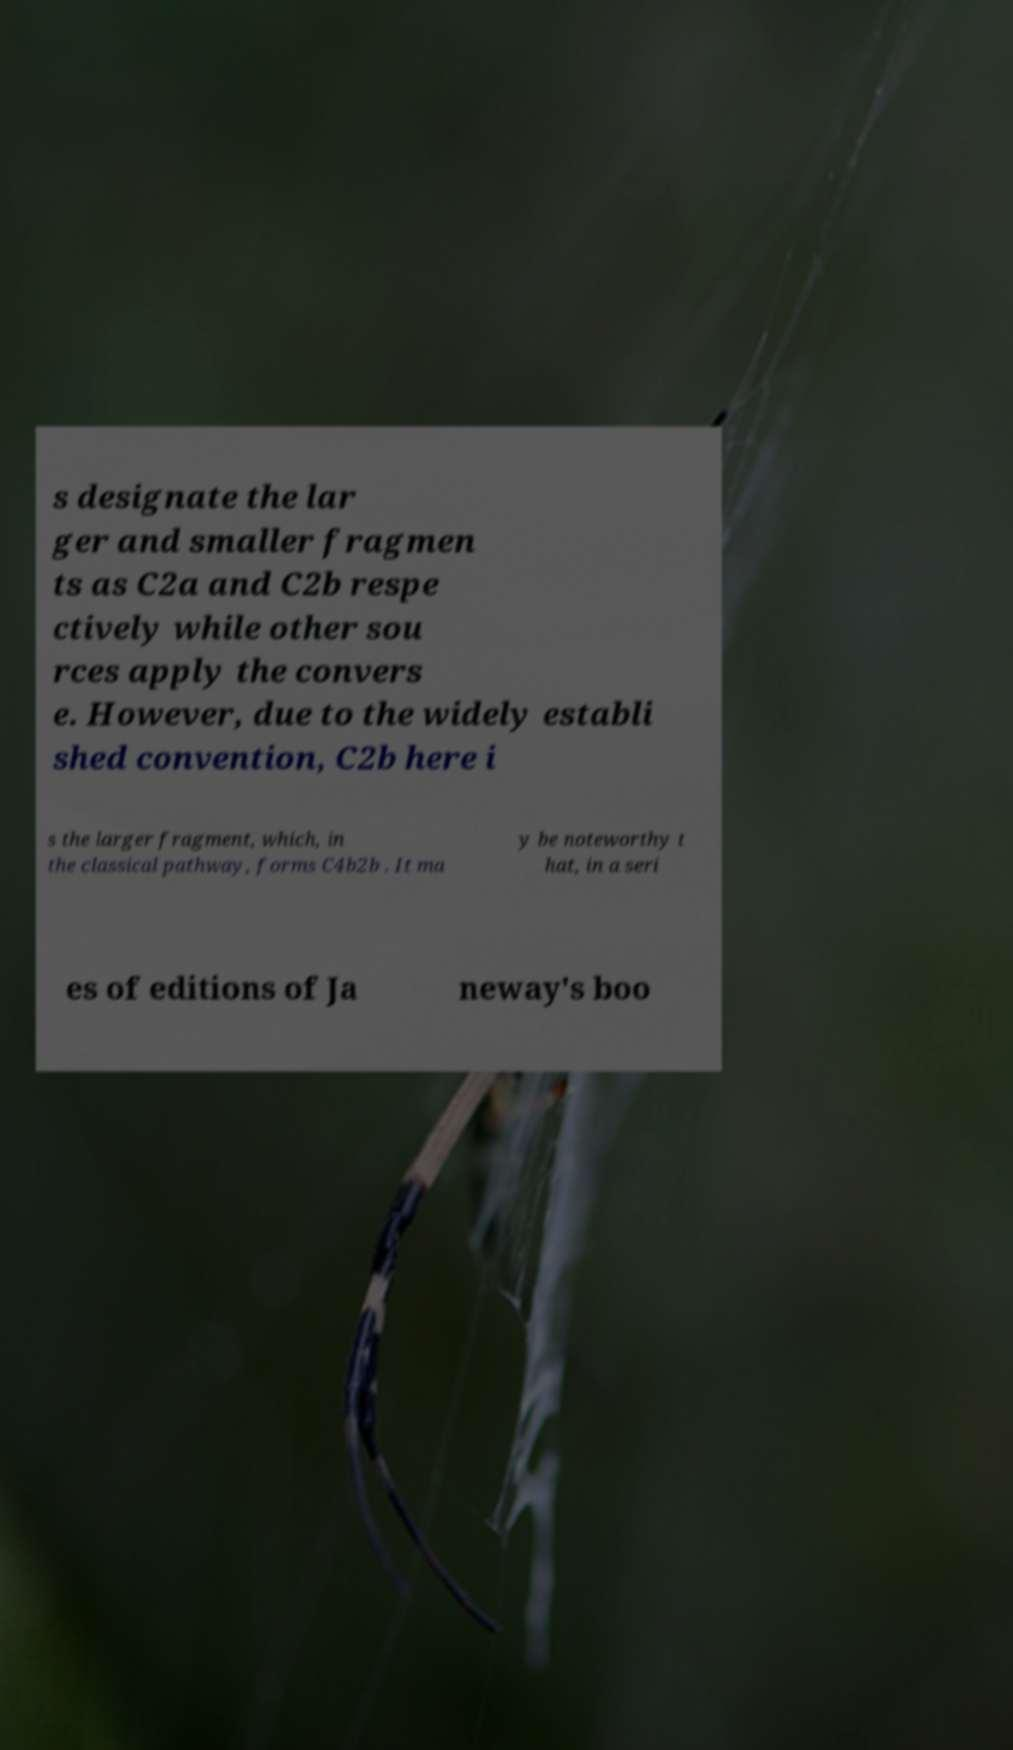For documentation purposes, I need the text within this image transcribed. Could you provide that? s designate the lar ger and smaller fragmen ts as C2a and C2b respe ctively while other sou rces apply the convers e. However, due to the widely establi shed convention, C2b here i s the larger fragment, which, in the classical pathway, forms C4b2b . It ma y be noteworthy t hat, in a seri es of editions of Ja neway's boo 